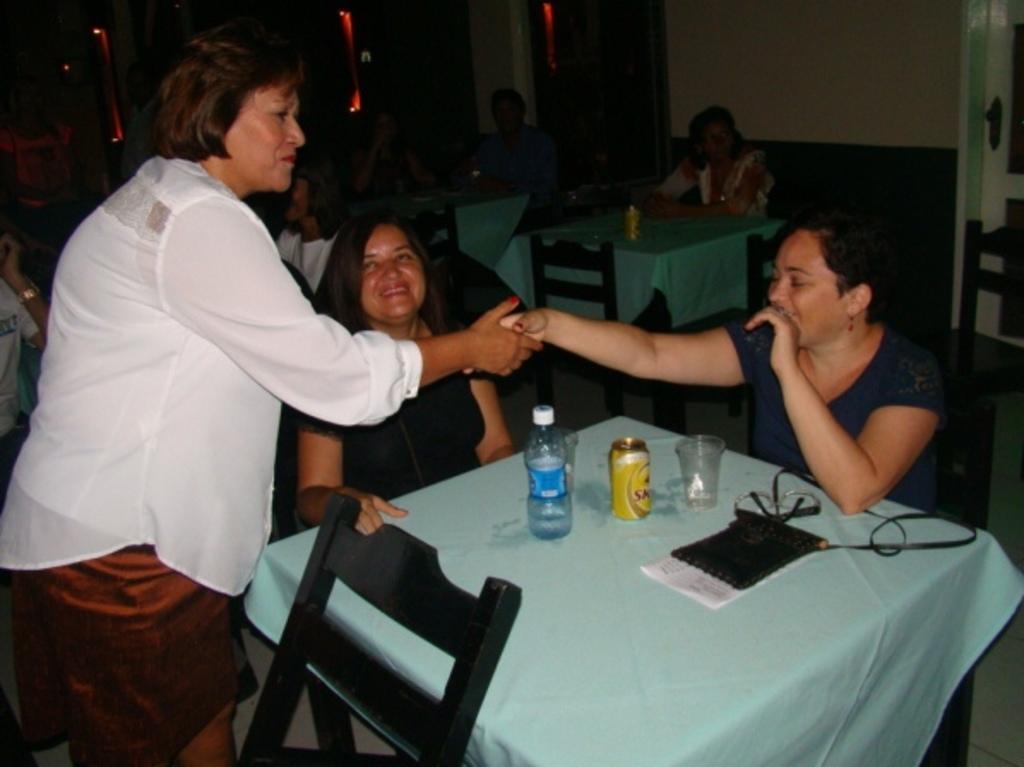Describe this image in one or two sentences. In this image we can see three women near the table. There are water bottle, glasses, tin and a bag placed on the table. In the background of the image we can see few more people. 